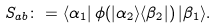Convert formula to latex. <formula><loc_0><loc_0><loc_500><loc_500>S _ { a b } \colon = \langle \alpha _ { 1 } | \, \phi ( | \alpha _ { 2 } \rangle \langle \beta _ { 2 } | ) \, | \beta _ { 1 } \rangle .</formula> 